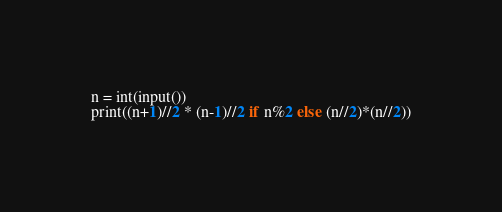Convert code to text. <code><loc_0><loc_0><loc_500><loc_500><_Python_>n = int(input())
print((n+1)//2 * (n-1)//2 if n%2 else (n//2)*(n//2))</code> 